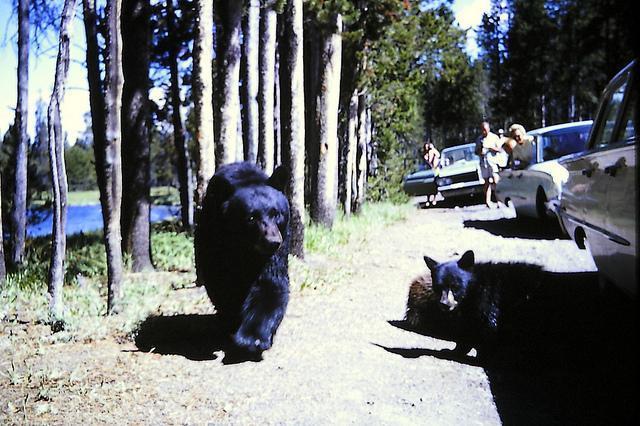How many cars are visible?
Give a very brief answer. 3. How many bears are there?
Give a very brief answer. 2. 